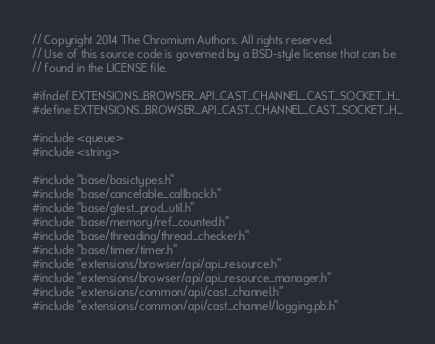<code> <loc_0><loc_0><loc_500><loc_500><_C_>// Copyright 2014 The Chromium Authors. All rights reserved.
// Use of this source code is governed by a BSD-style license that can be
// found in the LICENSE file.

#ifndef EXTENSIONS_BROWSER_API_CAST_CHANNEL_CAST_SOCKET_H_
#define EXTENSIONS_BROWSER_API_CAST_CHANNEL_CAST_SOCKET_H_

#include <queue>
#include <string>

#include "base/basictypes.h"
#include "base/cancelable_callback.h"
#include "base/gtest_prod_util.h"
#include "base/memory/ref_counted.h"
#include "base/threading/thread_checker.h"
#include "base/timer/timer.h"
#include "extensions/browser/api/api_resource.h"
#include "extensions/browser/api/api_resource_manager.h"
#include "extensions/common/api/cast_channel.h"
#include "extensions/common/api/cast_channel/logging.pb.h"</code> 